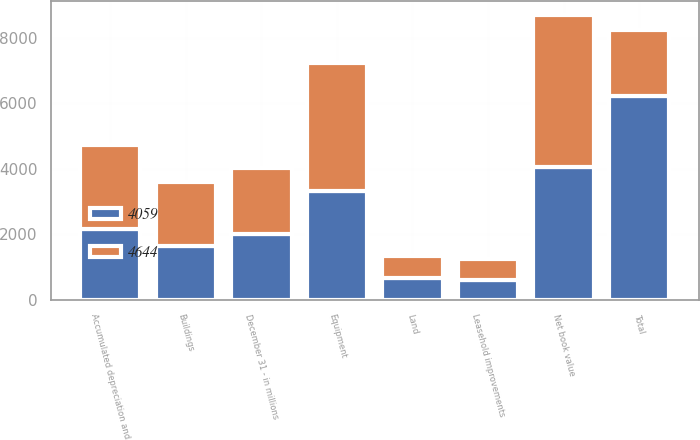<chart> <loc_0><loc_0><loc_500><loc_500><stacked_bar_chart><ecel><fcel>December 31 - in millions<fcel>Land<fcel>Buildings<fcel>Equipment<fcel>Leasehold improvements<fcel>Total<fcel>Accumulated depreciation and<fcel>Net book value<nl><fcel>4644<fcel>2011<fcel>690<fcel>1955<fcel>3894<fcel>651<fcel>2011<fcel>2546<fcel>4644<nl><fcel>4059<fcel>2010<fcel>659<fcel>1644<fcel>3335<fcel>593<fcel>6231<fcel>2172<fcel>4059<nl></chart> 